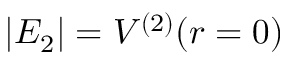Convert formula to latex. <formula><loc_0><loc_0><loc_500><loc_500>| E _ { 2 } | = V ^ { ( 2 ) } ( r = 0 )</formula> 